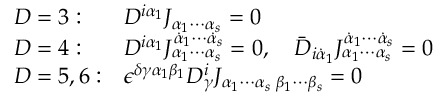Convert formula to latex. <formula><loc_0><loc_0><loc_500><loc_500>\begin{array} { l l } { D = 3 \colon } & { { D ^ { i \alpha _ { 1 } } J _ { \alpha _ { 1 } \cdots \alpha _ { s } } = 0 } } \\ { D = 4 \colon } & { { D ^ { i \alpha _ { 1 } } J _ { \alpha _ { 1 } \cdots \alpha _ { s } } ^ { \dot { \alpha } _ { 1 } \cdots \dot { \alpha } _ { s } } = 0 , \quad \bar { D } _ { i \dot { \alpha } _ { 1 } } J _ { \alpha _ { 1 } \cdots \alpha _ { s } } ^ { \dot { \alpha } _ { 1 } \cdots \dot { \alpha } _ { s } } = 0 } } \\ { D = 5 , 6 \colon } & { { \epsilon ^ { \delta \gamma \alpha _ { 1 } \beta _ { 1 } } D _ { \gamma } ^ { i } J _ { \alpha _ { 1 } \cdots \alpha _ { s } \, \beta _ { 1 } \cdots \beta _ { s } } = 0 } } \end{array}</formula> 